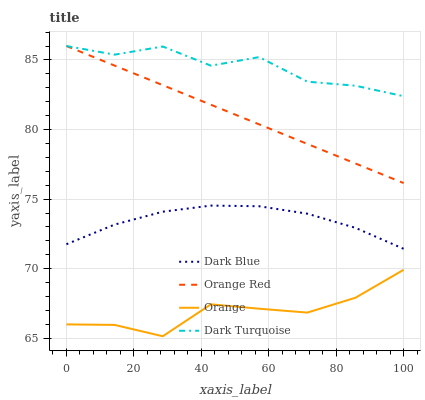Does Orange have the minimum area under the curve?
Answer yes or no. Yes. Does Dark Turquoise have the maximum area under the curve?
Answer yes or no. Yes. Does Dark Blue have the minimum area under the curve?
Answer yes or no. No. Does Dark Blue have the maximum area under the curve?
Answer yes or no. No. Is Orange Red the smoothest?
Answer yes or no. Yes. Is Dark Turquoise the roughest?
Answer yes or no. Yes. Is Dark Blue the smoothest?
Answer yes or no. No. Is Dark Blue the roughest?
Answer yes or no. No. Does Orange have the lowest value?
Answer yes or no. Yes. Does Dark Blue have the lowest value?
Answer yes or no. No. Does Dark Turquoise have the highest value?
Answer yes or no. Yes. Does Dark Blue have the highest value?
Answer yes or no. No. Is Orange less than Orange Red?
Answer yes or no. Yes. Is Orange Red greater than Dark Blue?
Answer yes or no. Yes. Does Dark Turquoise intersect Orange Red?
Answer yes or no. Yes. Is Dark Turquoise less than Orange Red?
Answer yes or no. No. Is Dark Turquoise greater than Orange Red?
Answer yes or no. No. Does Orange intersect Orange Red?
Answer yes or no. No. 